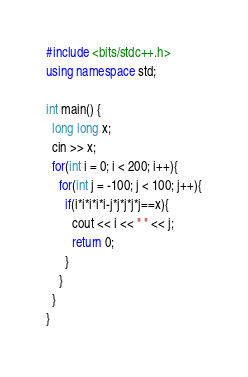<code> <loc_0><loc_0><loc_500><loc_500><_C++_>#include <bits/stdc++.h>
using namespace std;
 
int main() {
  long long x;
  cin >> x;
  for(int i = 0; i < 200; i++){
    for(int j = -100; j < 100; j++){
      if(i*i*i*i*i-j*j*j*j*j==x){
        cout << i << " " << j;
        return 0;
      }
    }
  }
}</code> 